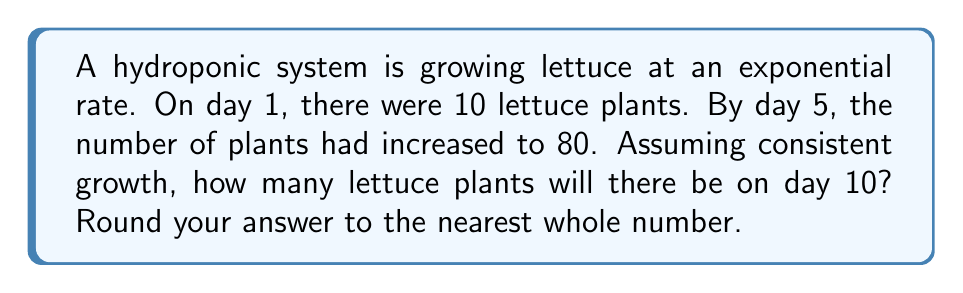Could you help me with this problem? Let's approach this step-by-step:

1) We're dealing with exponential growth, which can be modeled by the equation:
   
   $A = P(1 + r)^t$

   Where:
   $A$ = Final amount
   $P$ = Initial amount
   $r$ = Growth rate (per day)
   $t$ = Time (in days)

2) We know:
   $P = 10$ (initial number of plants)
   $A = 80$ (number of plants on day 5)
   $t = 4$ (from day 1 to day 5 is 4 days)

3) Let's plug these into our equation:
   
   $80 = 10(1 + r)^4$

4) Solve for $r$:
   
   $\frac{80}{10} = (1 + r)^4$
   $8 = (1 + r)^4$
   $\sqrt[4]{8} = 1 + r$
   $1.68179... = 1 + r$
   $r \approx 0.68179$ or about 68.18% daily growth rate

5) Now that we know the growth rate, we can calculate the number of plants on day 10:
   
   $A = 10(1 + 0.68179)^9$ (9 days from day 1 to day 10)

6) Calculate:
   
   $A \approx 10 * 101.59 \approx 1015.9$

7) Rounding to the nearest whole number: 1016 plants

This exponential growth demonstrates how quickly produce can multiply in optimal hydroponic conditions, allowing for efficient use of space and resources in urban farming.
Answer: 1016 plants 